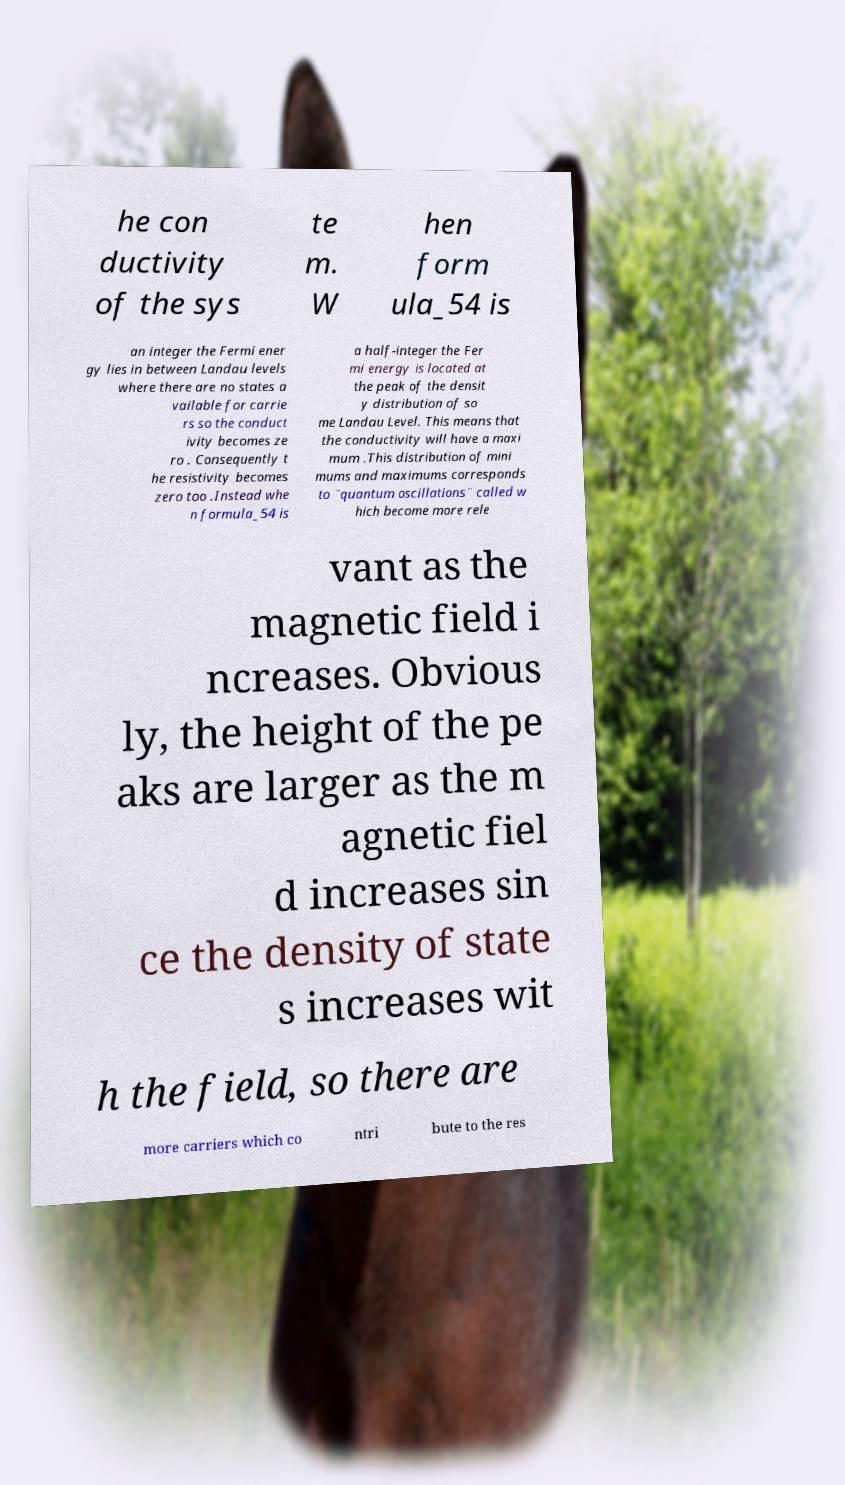Please read and relay the text visible in this image. What does it say? he con ductivity of the sys te m. W hen form ula_54 is an integer the Fermi ener gy lies in between Landau levels where there are no states a vailable for carrie rs so the conduct ivity becomes ze ro . Consequently t he resistivity becomes zero too .Instead whe n formula_54 is a half-integer the Fer mi energy is located at the peak of the densit y distribution of so me Landau Level. This means that the conductivity will have a maxi mum .This distribution of mini mums and maximums corresponds to ¨quantum oscillations¨ called w hich become more rele vant as the magnetic field i ncreases. Obvious ly, the height of the pe aks are larger as the m agnetic fiel d increases sin ce the density of state s increases wit h the field, so there are more carriers which co ntri bute to the res 